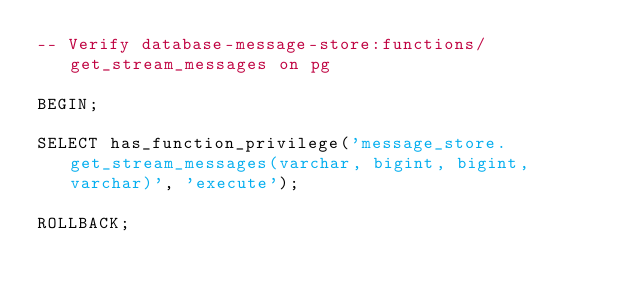Convert code to text. <code><loc_0><loc_0><loc_500><loc_500><_SQL_>-- Verify database-message-store:functions/get_stream_messages on pg

BEGIN;

SELECT has_function_privilege('message_store.get_stream_messages(varchar, bigint, bigint, varchar)', 'execute');

ROLLBACK;
</code> 